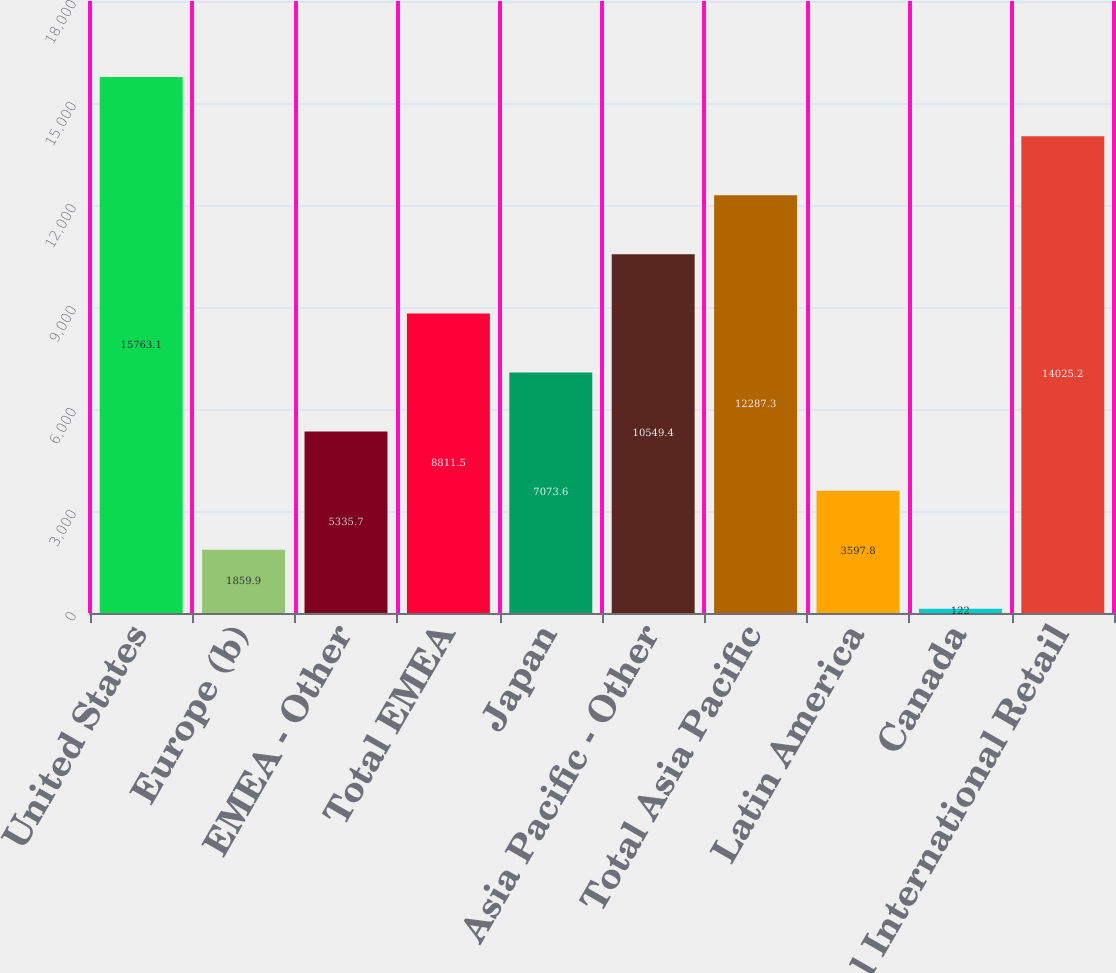Convert chart. <chart><loc_0><loc_0><loc_500><loc_500><bar_chart><fcel>United States<fcel>Europe (b)<fcel>EMEA - Other<fcel>Total EMEA<fcel>Japan<fcel>Asia Pacific - Other<fcel>Total Asia Pacific<fcel>Latin America<fcel>Canada<fcel>Total International Retail<nl><fcel>15763.1<fcel>1859.9<fcel>5335.7<fcel>8811.5<fcel>7073.6<fcel>10549.4<fcel>12287.3<fcel>3597.8<fcel>122<fcel>14025.2<nl></chart> 